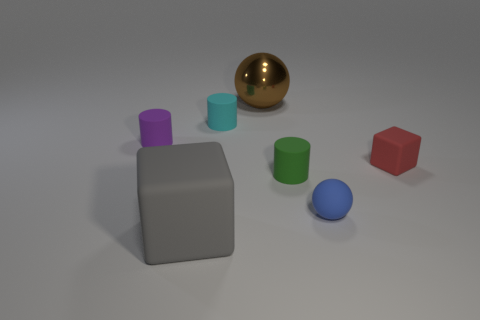Add 3 blue matte balls. How many objects exist? 10 Subtract all cylinders. How many objects are left? 4 Subtract 0 cyan balls. How many objects are left? 7 Subtract all purple cylinders. Subtract all small cyan matte things. How many objects are left? 5 Add 6 gray matte things. How many gray matte things are left? 7 Add 4 green things. How many green things exist? 5 